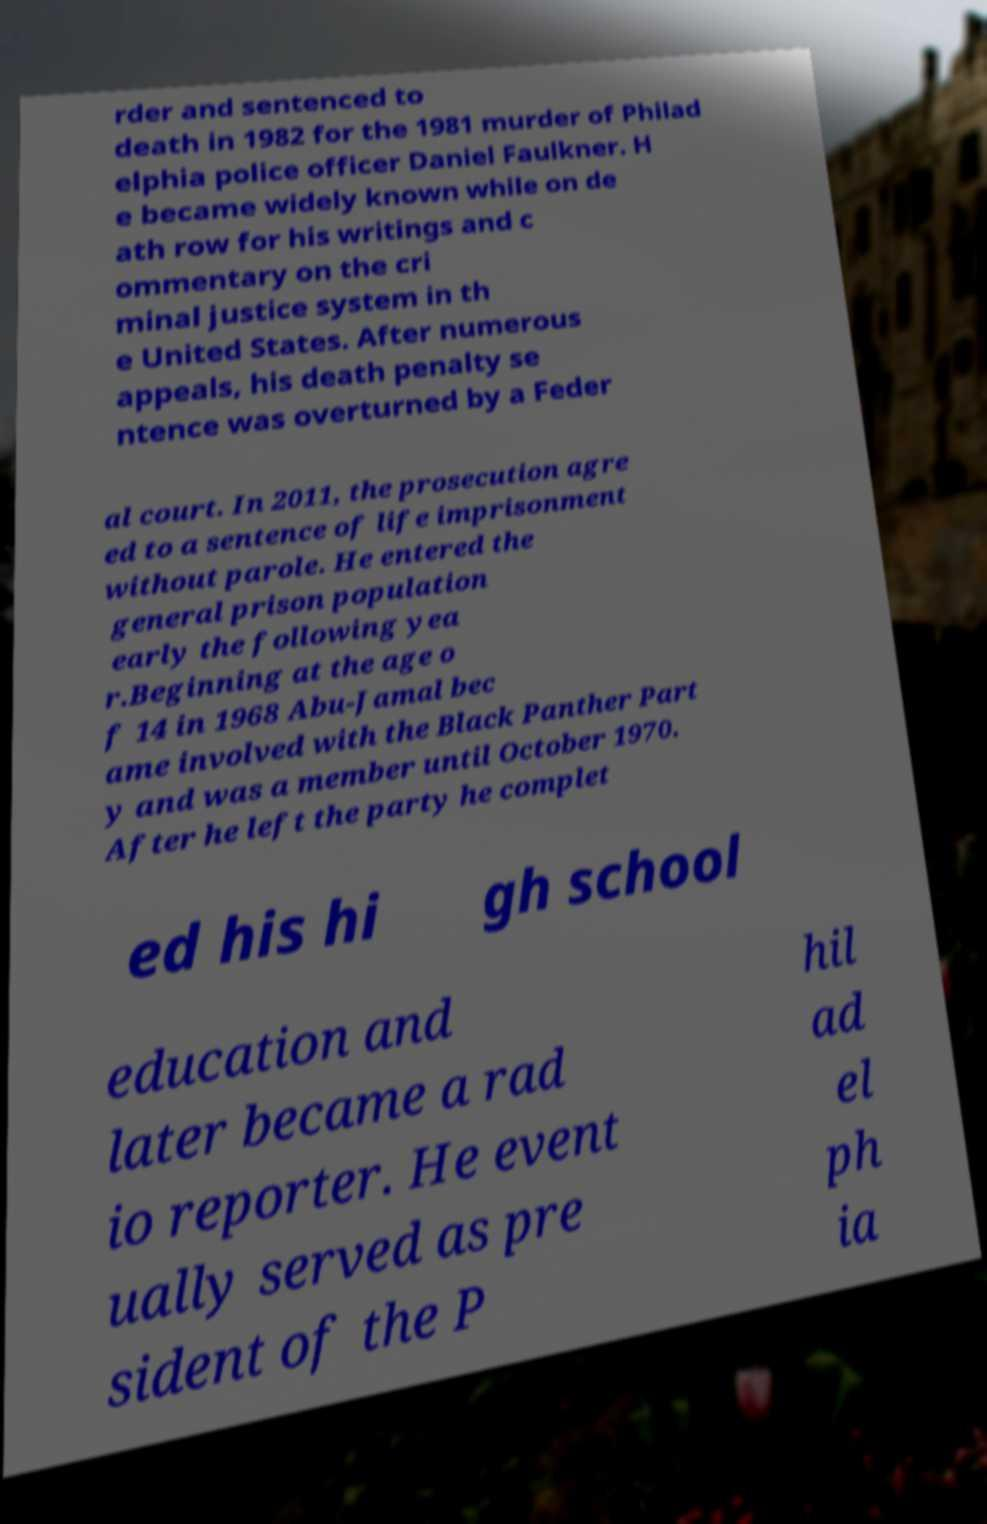I need the written content from this picture converted into text. Can you do that? rder and sentenced to death in 1982 for the 1981 murder of Philad elphia police officer Daniel Faulkner. H e became widely known while on de ath row for his writings and c ommentary on the cri minal justice system in th e United States. After numerous appeals, his death penalty se ntence was overturned by a Feder al court. In 2011, the prosecution agre ed to a sentence of life imprisonment without parole. He entered the general prison population early the following yea r.Beginning at the age o f 14 in 1968 Abu-Jamal bec ame involved with the Black Panther Part y and was a member until October 1970. After he left the party he complet ed his hi gh school education and later became a rad io reporter. He event ually served as pre sident of the P hil ad el ph ia 